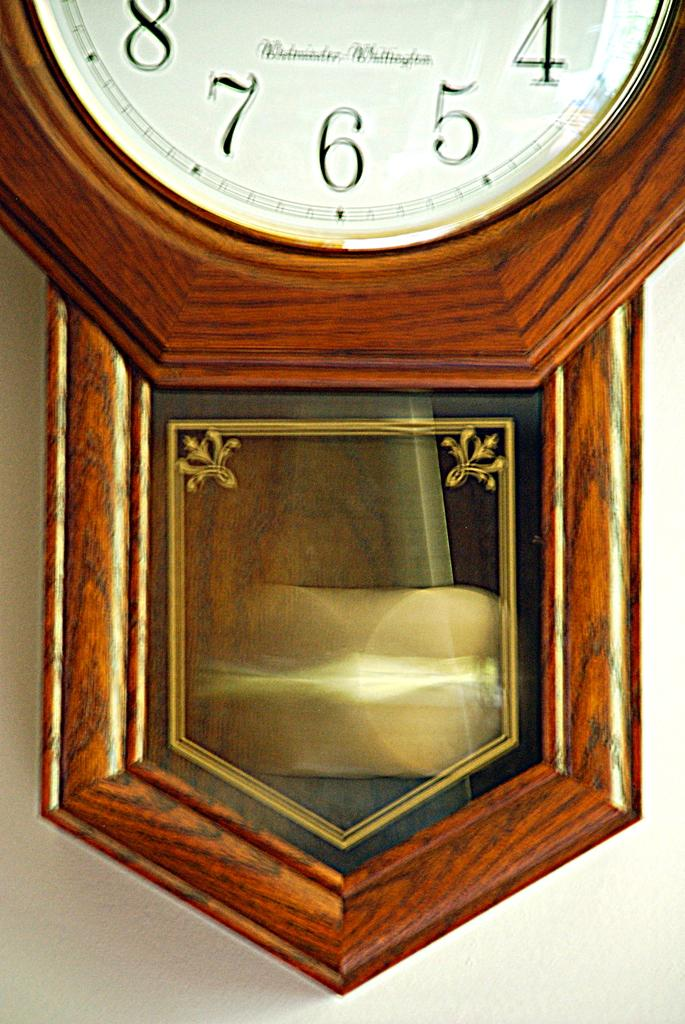<image>
Relay a brief, clear account of the picture shown. The bottom of a clock is shown and the highest number that can be seen is 8. 